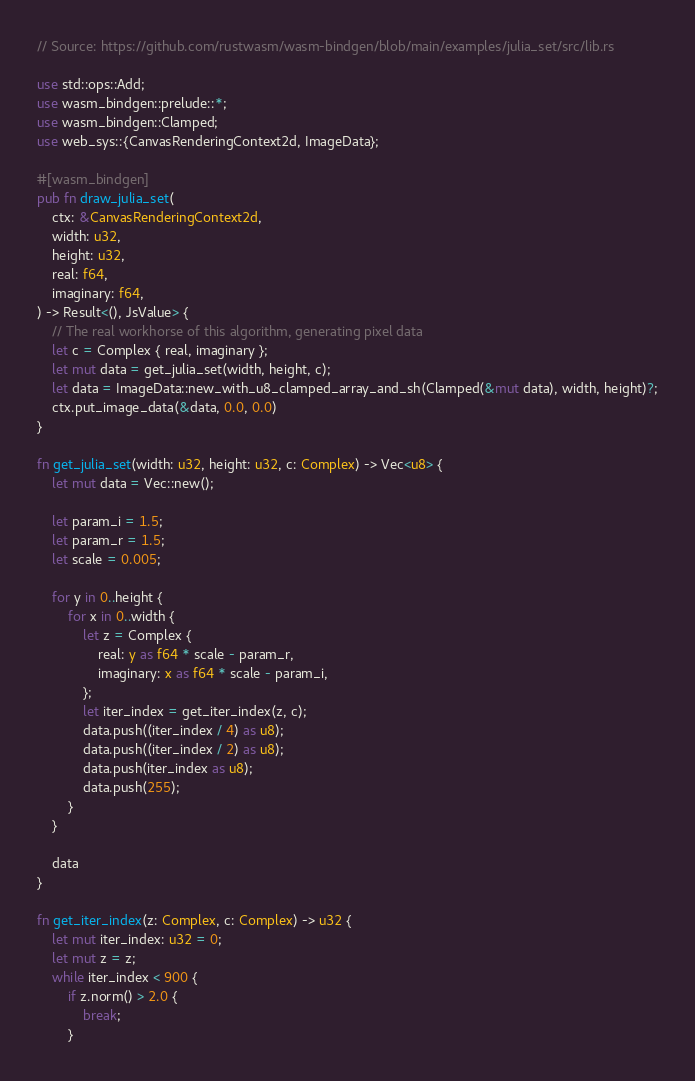Convert code to text. <code><loc_0><loc_0><loc_500><loc_500><_Rust_>// Source: https://github.com/rustwasm/wasm-bindgen/blob/main/examples/julia_set/src/lib.rs

use std::ops::Add;
use wasm_bindgen::prelude::*;
use wasm_bindgen::Clamped;
use web_sys::{CanvasRenderingContext2d, ImageData};

#[wasm_bindgen]
pub fn draw_julia_set(
    ctx: &CanvasRenderingContext2d,
    width: u32,
    height: u32,
    real: f64,
    imaginary: f64,
) -> Result<(), JsValue> {
    // The real workhorse of this algorithm, generating pixel data
    let c = Complex { real, imaginary };
    let mut data = get_julia_set(width, height, c);
    let data = ImageData::new_with_u8_clamped_array_and_sh(Clamped(&mut data), width, height)?;
    ctx.put_image_data(&data, 0.0, 0.0)
}

fn get_julia_set(width: u32, height: u32, c: Complex) -> Vec<u8> {
    let mut data = Vec::new();

    let param_i = 1.5;
    let param_r = 1.5;
    let scale = 0.005;

    for y in 0..height {
        for x in 0..width {
            let z = Complex {
                real: y as f64 * scale - param_r,
                imaginary: x as f64 * scale - param_i,
            };
            let iter_index = get_iter_index(z, c);
            data.push((iter_index / 4) as u8);
            data.push((iter_index / 2) as u8);
            data.push(iter_index as u8);
            data.push(255);
        }
    }

    data
}

fn get_iter_index(z: Complex, c: Complex) -> u32 {
    let mut iter_index: u32 = 0;
    let mut z = z;
    while iter_index < 900 {
        if z.norm() > 2.0 {
            break;
        }</code> 